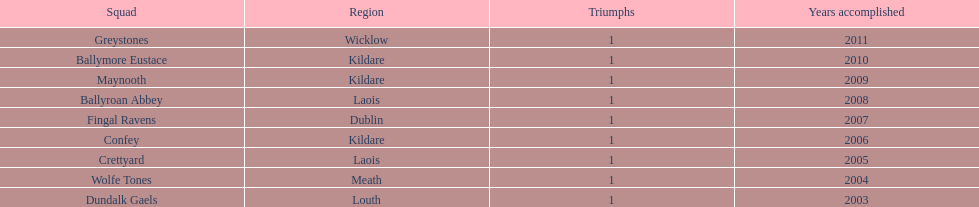What is the number of wins for confey 1. 